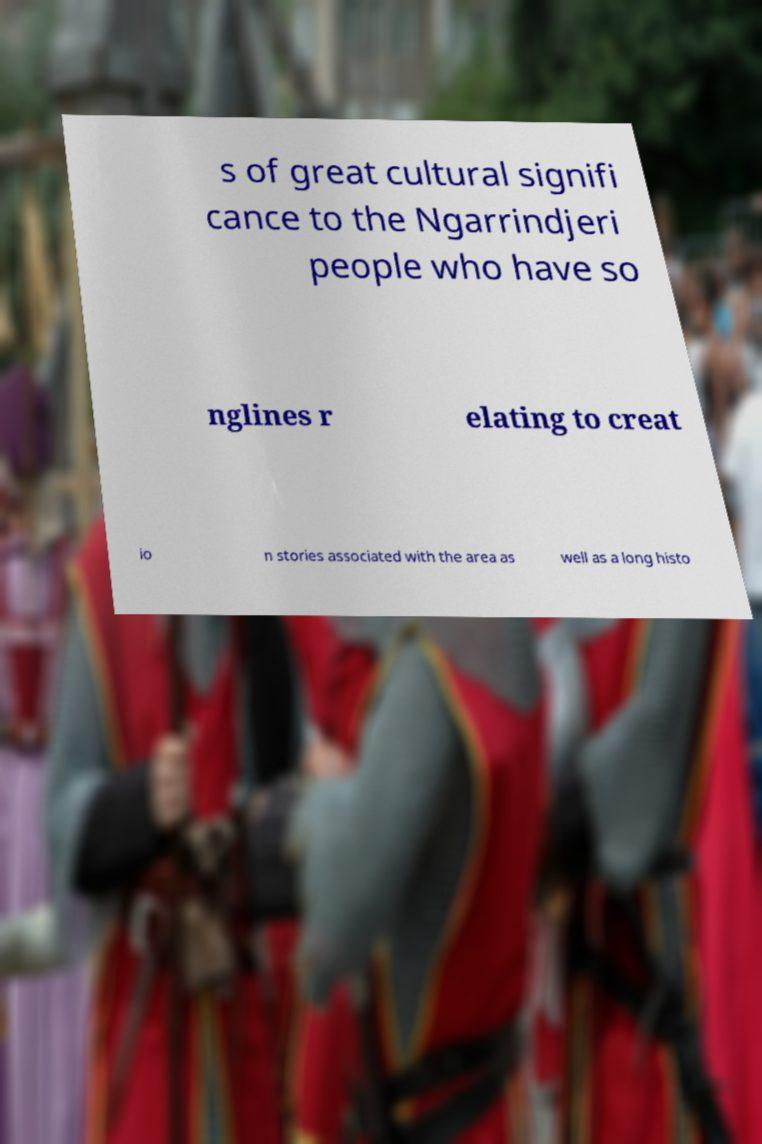For documentation purposes, I need the text within this image transcribed. Could you provide that? s of great cultural signifi cance to the Ngarrindjeri people who have so nglines r elating to creat io n stories associated with the area as well as a long histo 